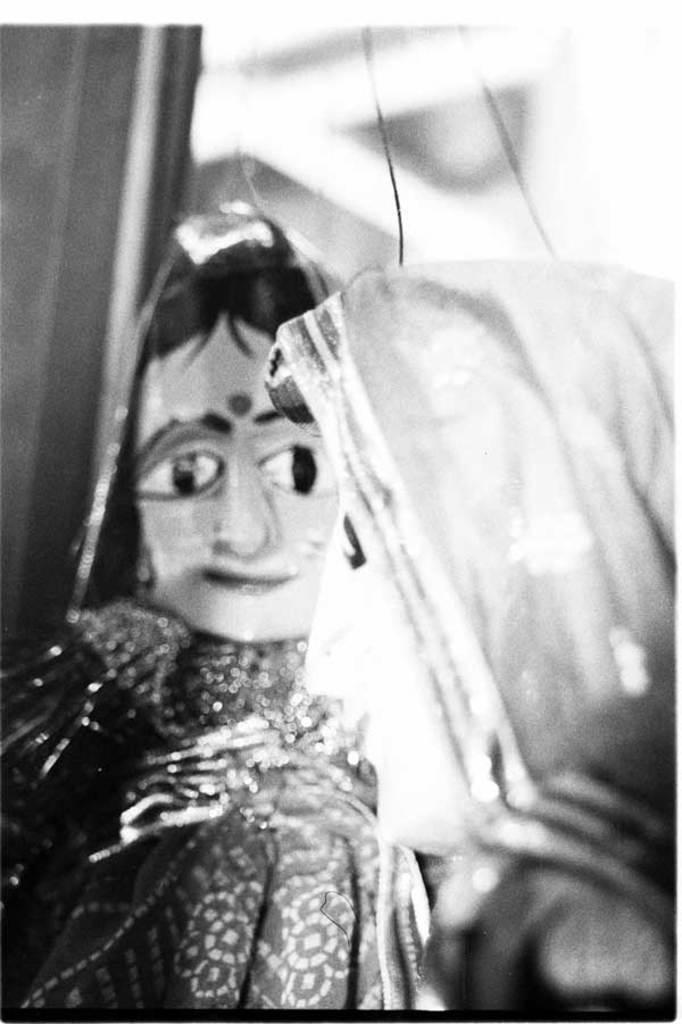What is the main subject of the image? The main subject of the image is puppetry. Can you describe the background of the image? The background of the image is blurred. What type of heat source is being used by the father in the image? There is no father or heat source present in the image, as it features puppetry and a blurred background. 